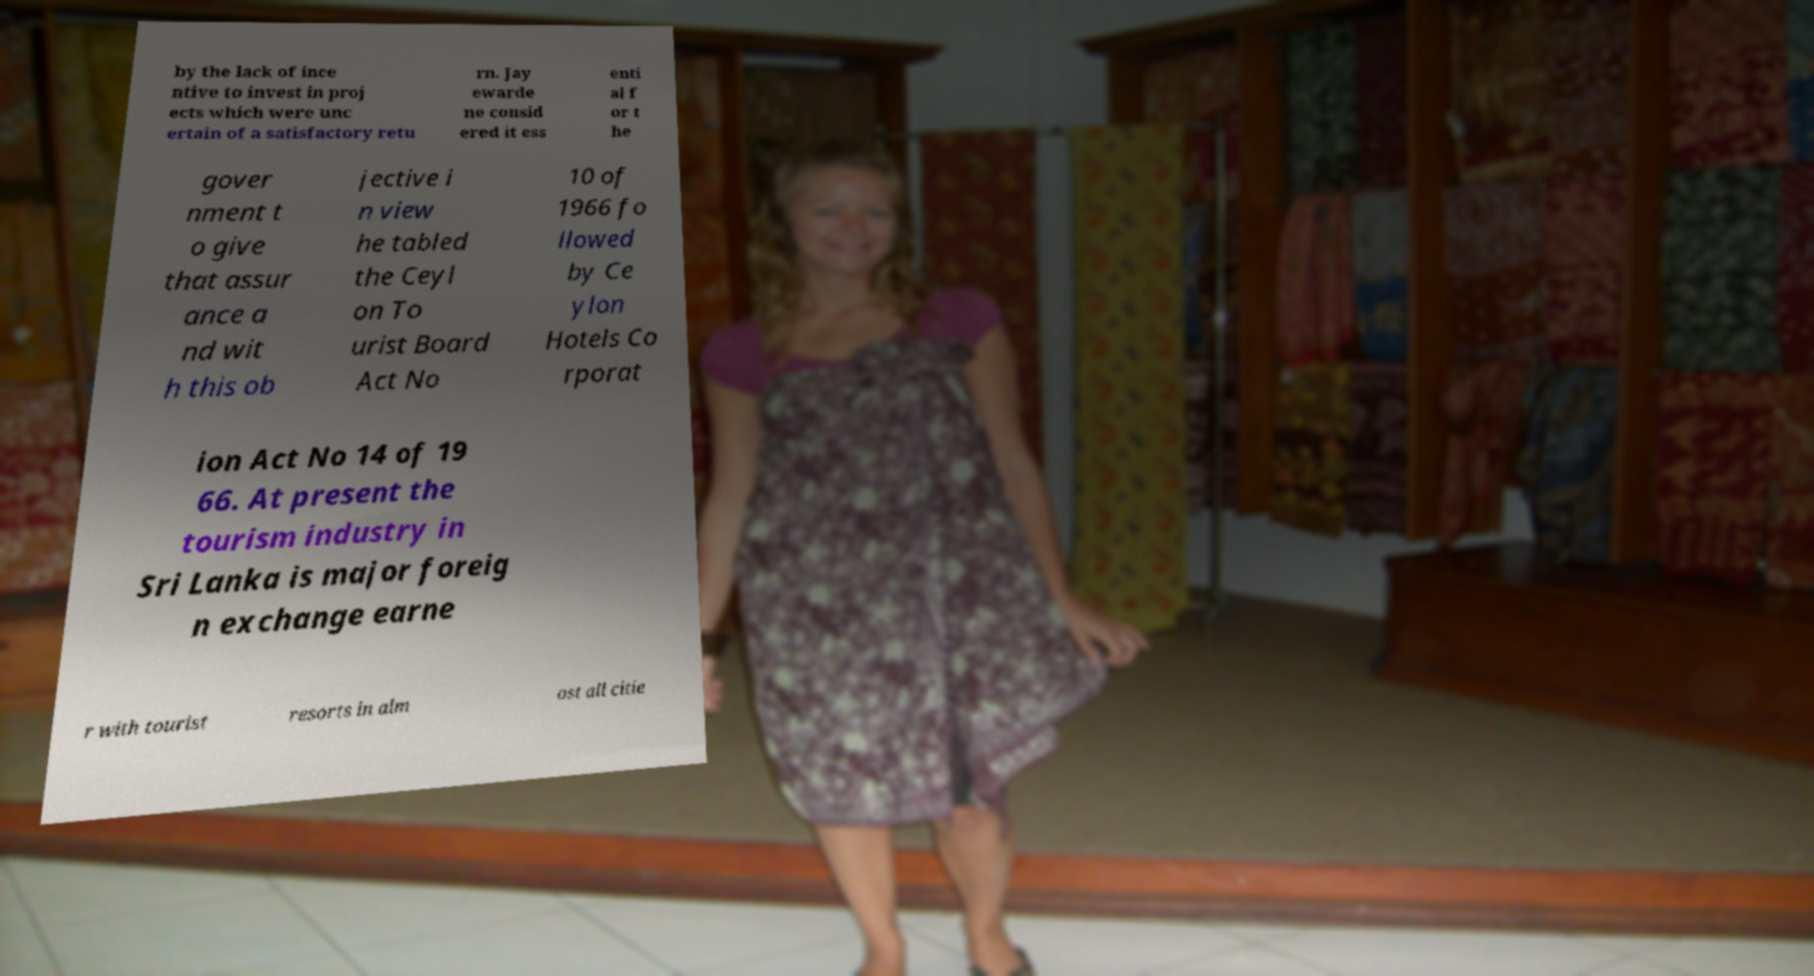There's text embedded in this image that I need extracted. Can you transcribe it verbatim? by the lack of ince ntive to invest in proj ects which were unc ertain of a satisfactory retu rn. Jay ewarde ne consid ered it ess enti al f or t he gover nment t o give that assur ance a nd wit h this ob jective i n view he tabled the Ceyl on To urist Board Act No 10 of 1966 fo llowed by Ce ylon Hotels Co rporat ion Act No 14 of 19 66. At present the tourism industry in Sri Lanka is major foreig n exchange earne r with tourist resorts in alm ost all citie 